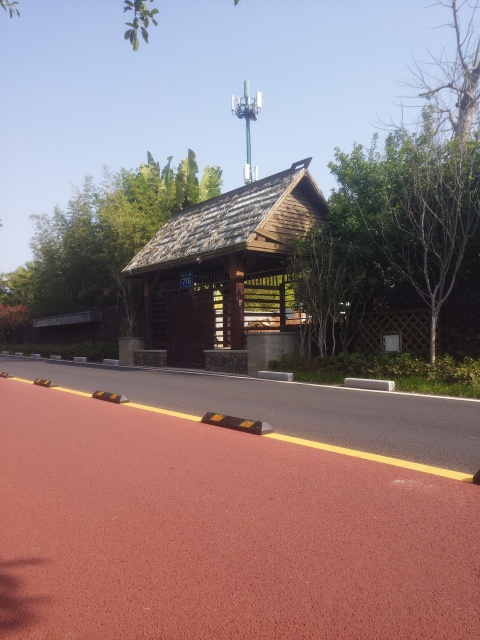Can you explain the function of that tower in the background? The tower in the background seems to be a telecommunications or cell phone tower, possibly containing antennas and microwave dishes for mobile phone networks. These are commonly placed in various locations to ensure adequate coverage for wireless communication services. Does this tower affect the aesthetic of the area? Opinions may vary, but some might feel that the presence of such modern infrastructure contrasts with the natural and rustic vibe of the location. However, it could also be seen as a juxtaposition that signifies the blend of modern technology with traditional designs. 